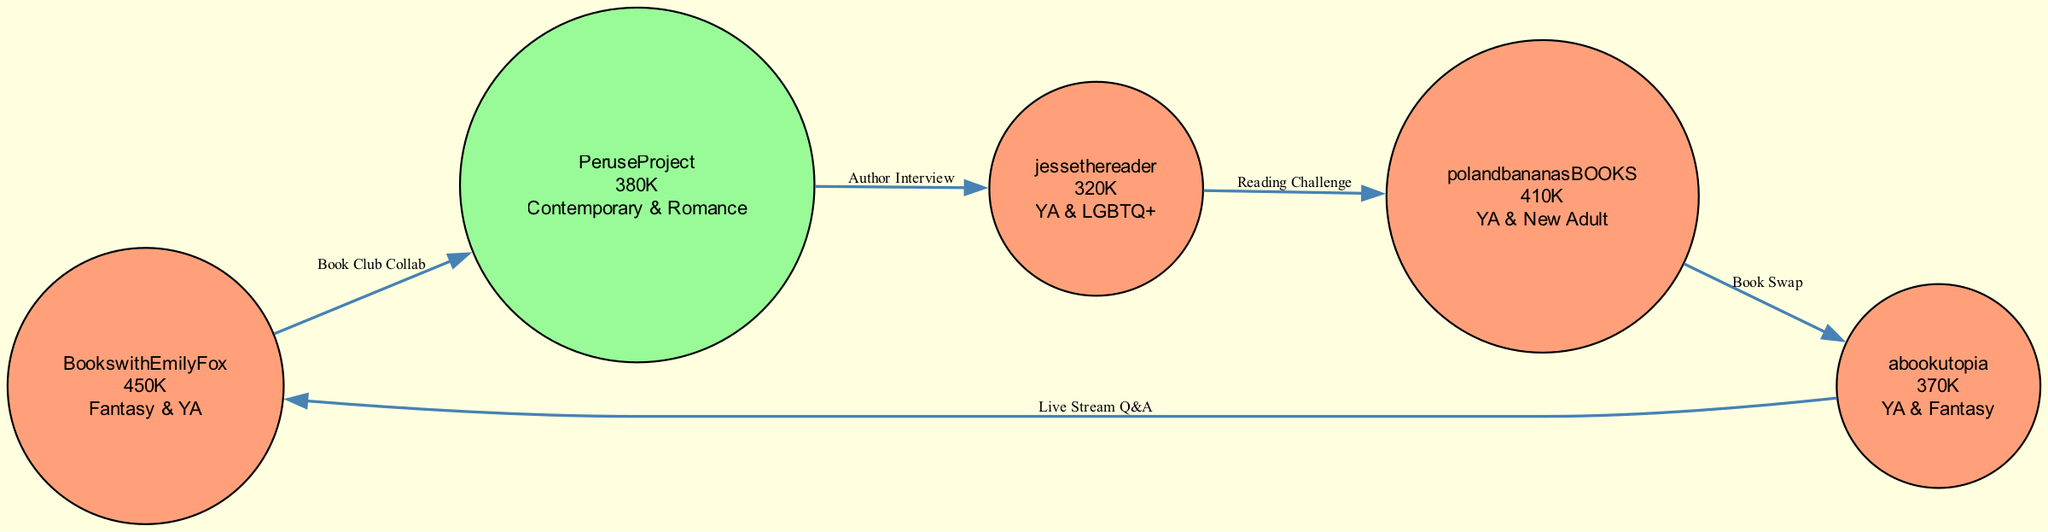What is the genre of BookswithEmilyFox? By inspecting the node representing BookswithEmilyFox, we see that it is categorized under the genre "Fantasy & YA."
Answer: Fantasy & YA How many subscribers does jessethereader have? Looking at the node for jessethereader, it is stated that this channel has 320K subscribers.
Answer: 320K What type of collaboration exists between PeruseProject and jessethereader? The edge connecting PeruseProject and jessethereader is labeled "Author Interview," indicating the type of collaboration between these two nodes.
Answer: Author Interview How many edges are present in the graph? By counting the connections (or edges) drawn between the nodes, we can determine that there are a total of 5 edges in this diagram.
Answer: 5 Which channel has the most subscribers? Examining all the nodes, BookswithEmilyFox has the highest subscriber count at 450K compared to the other channels listed.
Answer: BookswithEmilyFox Which genres are connected through reading challenges in this network? By tracing the edge labeled "Reading Challenge," we see that jessethereader (YA & LGBTQ+) connects with polandbananasBOOKS (YA & New Adult), linking both genres.
Answer: YA & LGBTQ+ and YA & New Adult In what type of collaboration do abookutopia and BookswithEmilyFox engage? The edge connecting abookutopia and BookswithEmilyFox is labeled "Live Stream Q&A," which specifies the kind of collaboration between these two channels.
Answer: Live Stream Q&A What is the total subscriber count of all channels combined? Adding the number of subscribers for each channel: 450K + 380K + 320K + 410K + 370K gives a total of 1930K subscribers across all channels.
Answer: 1930K Which two channels are involved in a book swap? The edge labeled "Book Swap" specifies that the channels polandbananasBOOKS and abookutopia are involved in this particular type of collaboration.
Answer: polandbananasBOOKS and abookutopia 